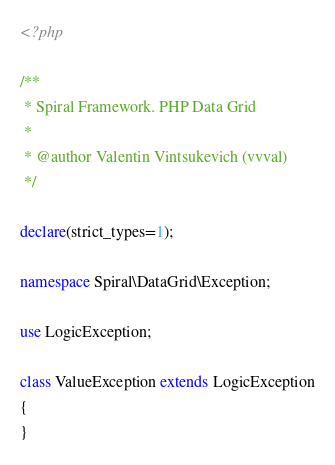Convert code to text. <code><loc_0><loc_0><loc_500><loc_500><_PHP_><?php

/**
 * Spiral Framework. PHP Data Grid
 *
 * @author Valentin Vintsukevich (vvval)
 */

declare(strict_types=1);

namespace Spiral\DataGrid\Exception;

use LogicException;

class ValueException extends LogicException
{
}
</code> 